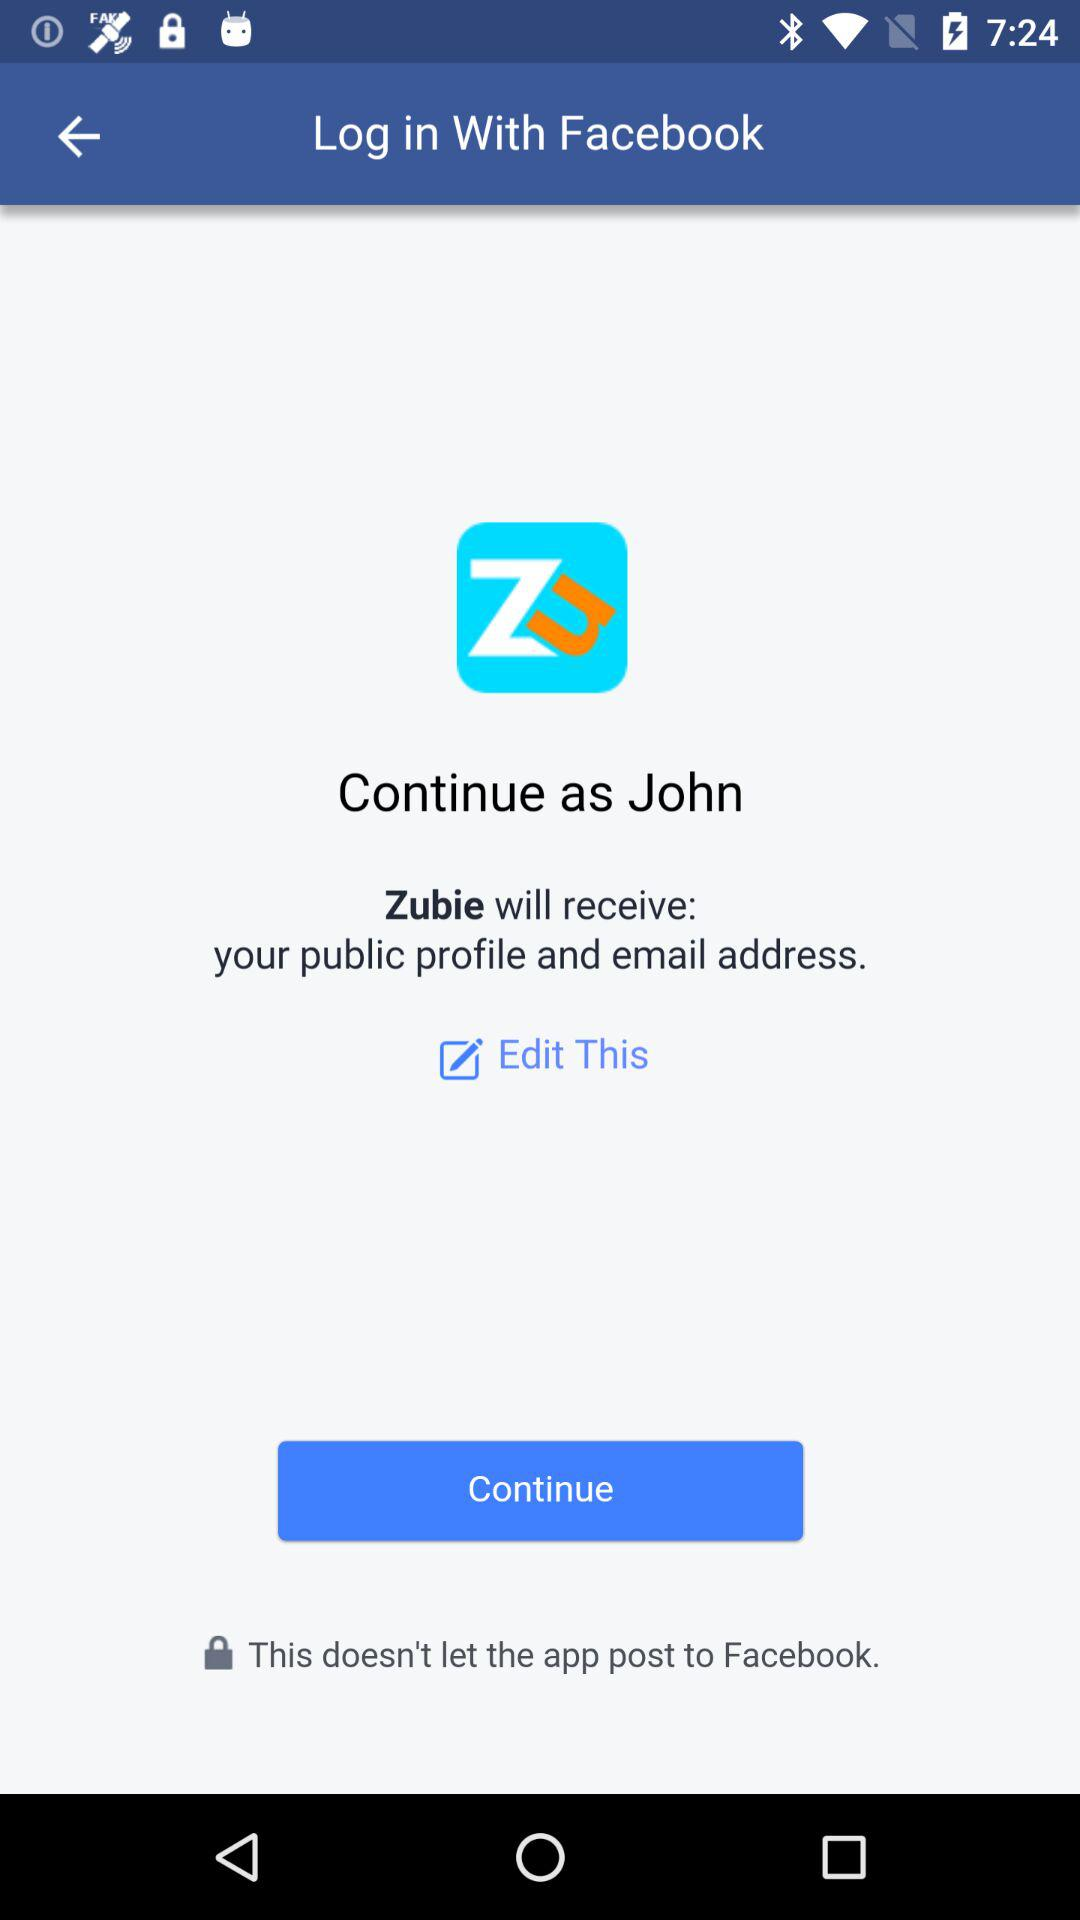What application is asking for permission? The application "Zubie" is asking for permission. 